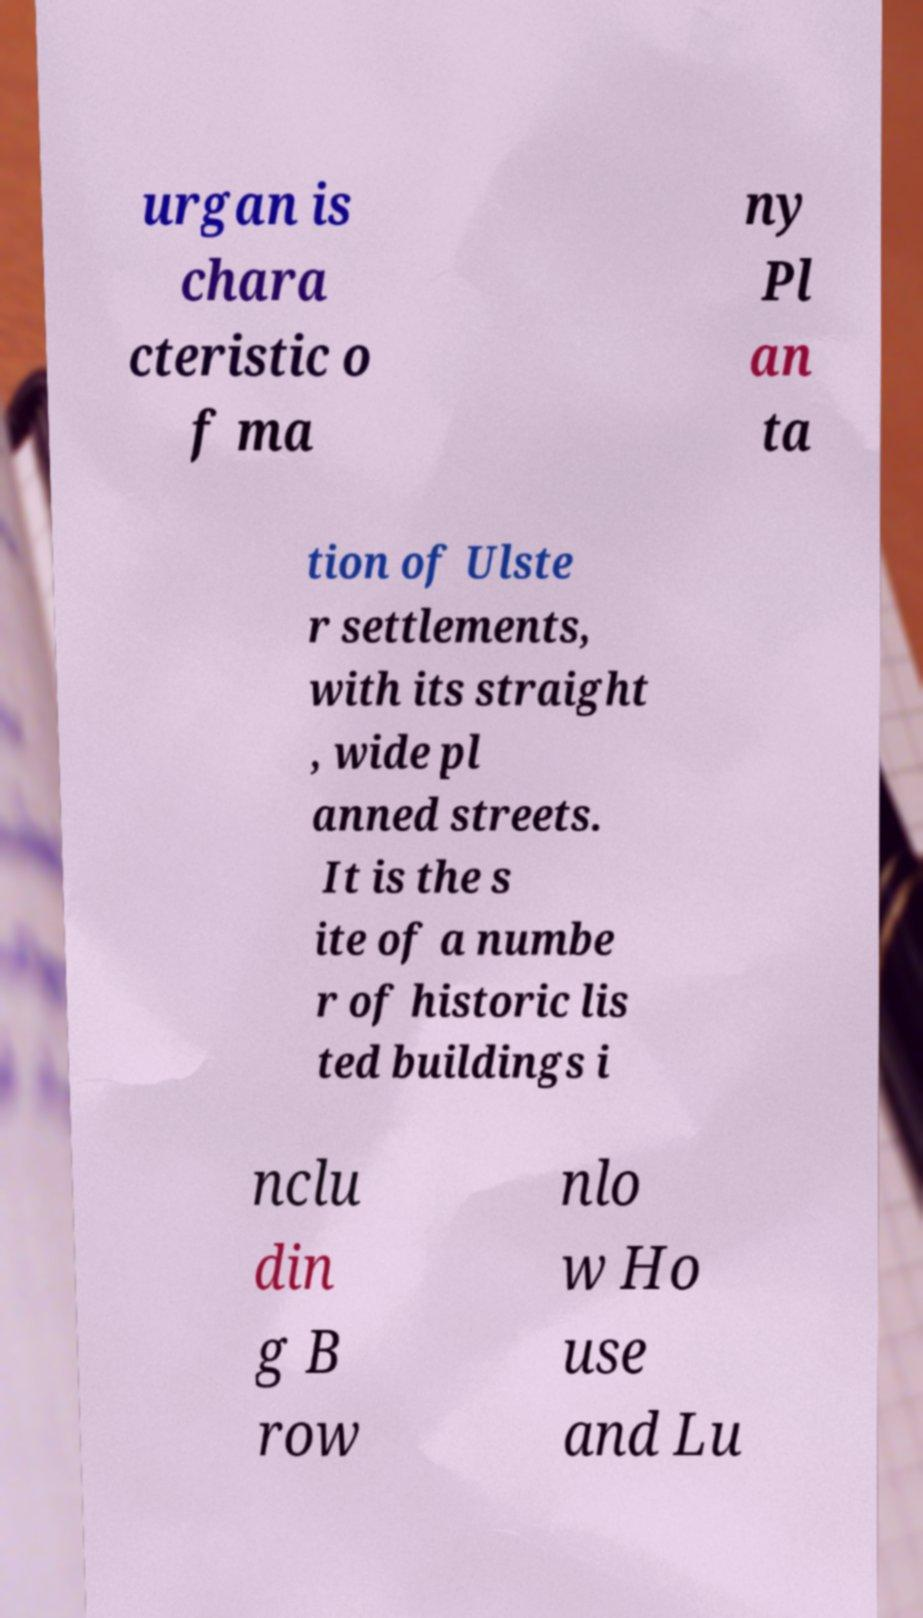For documentation purposes, I need the text within this image transcribed. Could you provide that? urgan is chara cteristic o f ma ny Pl an ta tion of Ulste r settlements, with its straight , wide pl anned streets. It is the s ite of a numbe r of historic lis ted buildings i nclu din g B row nlo w Ho use and Lu 